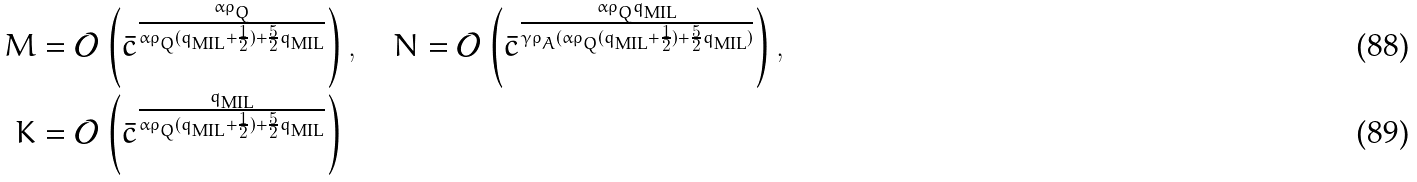Convert formula to latex. <formula><loc_0><loc_0><loc_500><loc_500>M & = \mathcal { O } \left ( \bar { c } ^ { \frac { \alpha \rho _ { Q } } { \alpha \rho _ { Q } ( q _ { \text {MIL} } + \frac { 1 } { 2 } ) + \frac { 5 } { 2 } q _ { \text {MIL} } } } \right ) , \quad N = \mathcal { O } \left ( \bar { c } ^ { \frac { \alpha \rho _ { Q } q _ { \text {MIL} } } { \gamma \rho _ { A } ( \alpha \rho _ { Q } ( q _ { \text {MIL} } + \frac { 1 } { 2 } ) + \frac { 5 } { 2 } q _ { \text {MIL} } ) } } \right ) , \\ K & = \mathcal { O } \left ( \bar { c } ^ { \frac { q _ { \text {MIL} } } { \alpha \rho _ { Q } ( q _ { \text {MIL} } + \frac { 1 } { 2 } ) + \frac { 5 } { 2 } q _ { \text {MIL} } } } \right )</formula> 